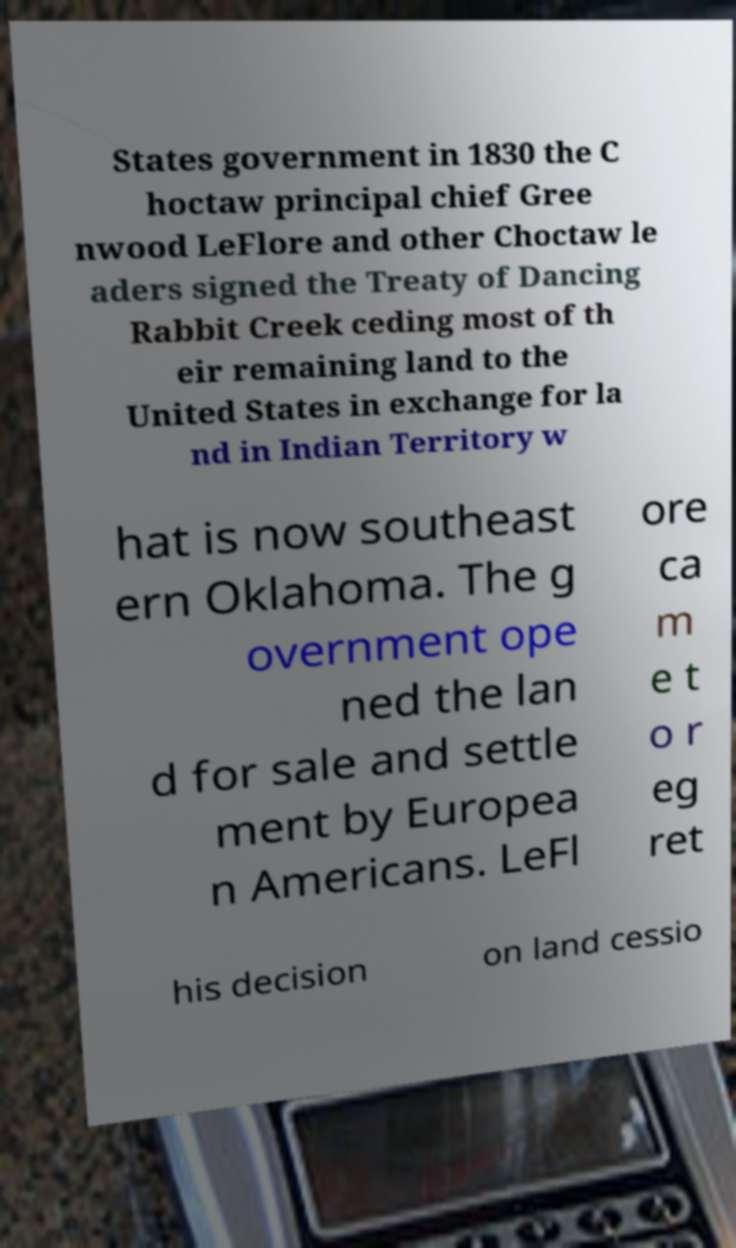For documentation purposes, I need the text within this image transcribed. Could you provide that? States government in 1830 the C hoctaw principal chief Gree nwood LeFlore and other Choctaw le aders signed the Treaty of Dancing Rabbit Creek ceding most of th eir remaining land to the United States in exchange for la nd in Indian Territory w hat is now southeast ern Oklahoma. The g overnment ope ned the lan d for sale and settle ment by Europea n Americans. LeFl ore ca m e t o r eg ret his decision on land cessio 